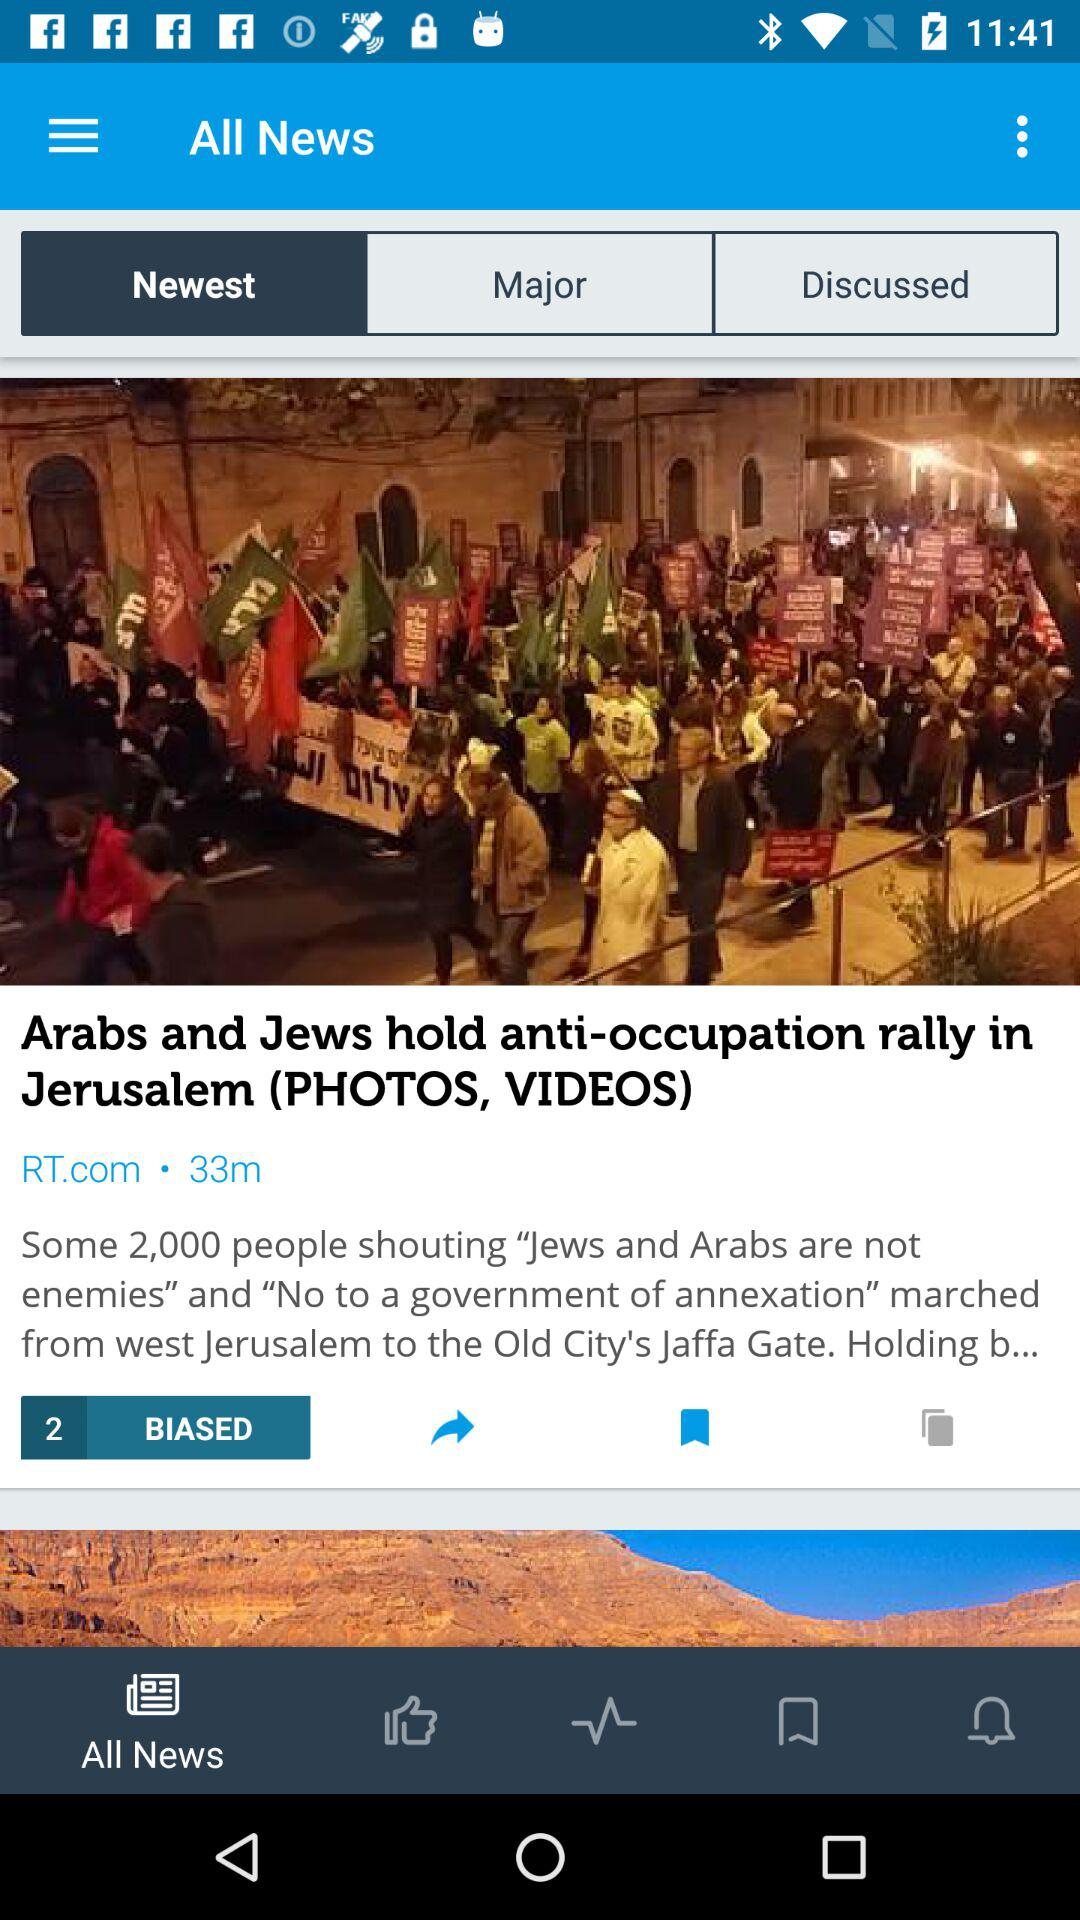What is the headline of the news? The headline is "Arabs and Jews hold anti-occupation rally in Jerusalem (PHOTOS, VIDEOS)". 